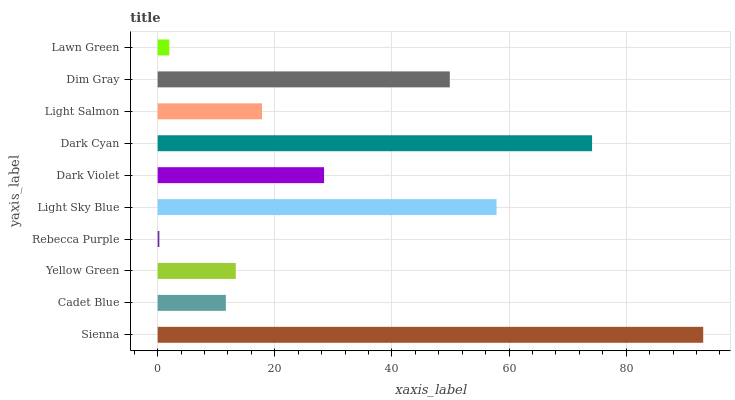Is Rebecca Purple the minimum?
Answer yes or no. Yes. Is Sienna the maximum?
Answer yes or no. Yes. Is Cadet Blue the minimum?
Answer yes or no. No. Is Cadet Blue the maximum?
Answer yes or no. No. Is Sienna greater than Cadet Blue?
Answer yes or no. Yes. Is Cadet Blue less than Sienna?
Answer yes or no. Yes. Is Cadet Blue greater than Sienna?
Answer yes or no. No. Is Sienna less than Cadet Blue?
Answer yes or no. No. Is Dark Violet the high median?
Answer yes or no. Yes. Is Light Salmon the low median?
Answer yes or no. Yes. Is Lawn Green the high median?
Answer yes or no. No. Is Dim Gray the low median?
Answer yes or no. No. 